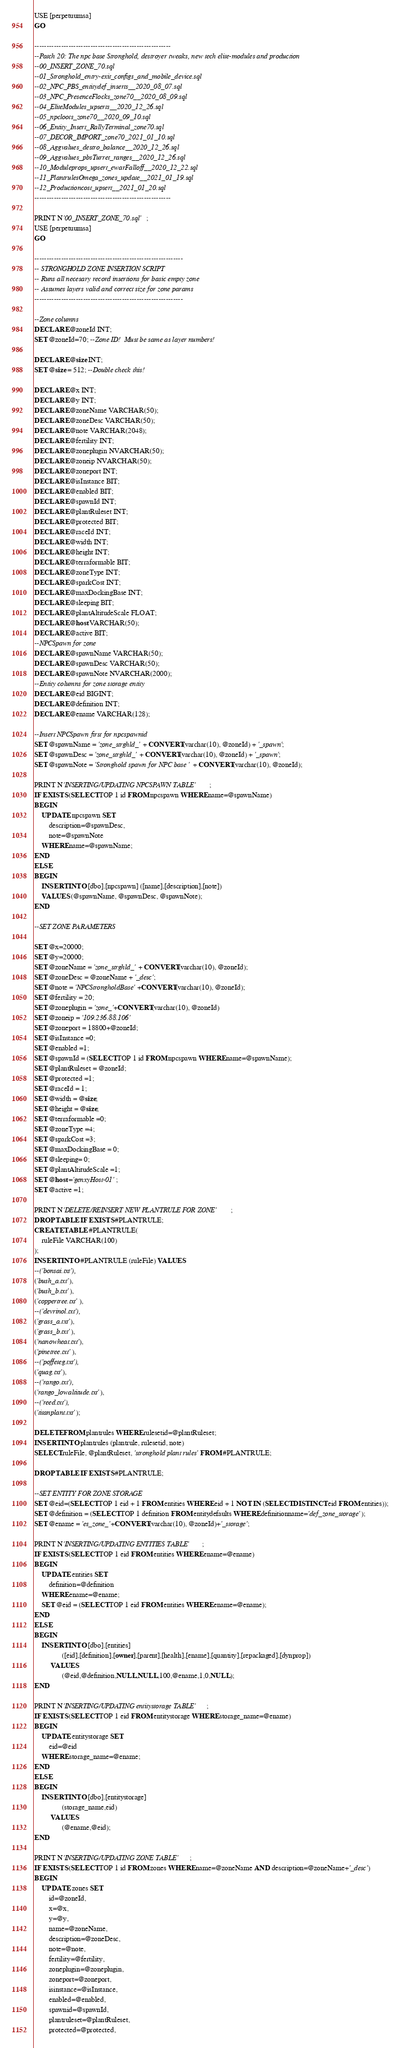<code> <loc_0><loc_0><loc_500><loc_500><_SQL_>USE [perpetuumsa]
GO

--------------------------------------------------------
--Patch 20: The npc base Stronghold, destroyer tweaks, new tech elite-modules and production
--00_INSERT_ZONE_70.sql
--01_Stronghold_entry-exit_configs_and_mobile_device.sql
--02_NPC_PBS_entitydef_inserts__2020_08_07.sql
--03_NPC_PresenceFlocks_zone70__2020_08_09.sql
--04_EliteModules_upserts__2020_12_26.sql
--05_npcloots_zone70__2020_09_10.sql
--06_Entity_Insert_RallyTerminal_zone70.sql
--07_DECOR_IMPORT_zone70_2021_01_10.sql
--08_Aggvalues_destro_balance__2020_12_26.sql
--09_Aggvalues_pbsTurret_ranges__2020_12_26.sql
--10_Moduleprops_upsert_ewarFalloff__2020_12_22.sql
--11_PlantrulesOmega_zones_update__2021_01_19.sql
--12_Productioncost_upsert__2021_01_20.sql
--------------------------------------------------------

PRINT N'00_INSERT_ZONE_70.sql';
USE [perpetuumsa]
GO

-------------------------------------------------------------
-- STRONGHOLD ZONE INSERTION SCRIPT
-- Runs all necesary record insertions for basic empty zone
-- Assumes layers valid and correct size for zone params
-------------------------------------------------------------

--Zone columns
DECLARE @zoneId INT;
SET @zoneId=70; --Zone ID!  Must be same as layer numbers!

DECLARE @size INT;
SET @size = 512; --Double check this!

DECLARE @x INT;
DECLARE @y INT;
DECLARE @zoneName VARCHAR(50);
DECLARE @zoneDesc VARCHAR(50);
DECLARE @note VARCHAR(2048);
DECLARE @fertility INT;
DECLARE @zoneplugin NVARCHAR(50);
DECLARE @zoneip NVARCHAR(50);
DECLARE @zoneport INT;
DECLARE @isInstance BIT;
DECLARE @enabled BIT;
DECLARE @spawnId INT;
DECLARE @plantRuleset INT;
DECLARE @protected BIT;
DECLARE @raceId INT;
DECLARE @width INT;
DECLARE @height INT;
DECLARE @terraformable BIT;
DECLARE @zoneType INT;
DECLARE @sparkCost INT;
DECLARE @maxDockingBase INT;
DECLARE @sleeping BIT;
DECLARE @plantAltitudeScale FLOAT;
DECLARE @host VARCHAR(50);
DECLARE @active BIT;
--NPCSpawn for zone
DECLARE @spawnName VARCHAR(50);
DECLARE @spawnDesc VARCHAR(50);
DECLARE @spawnNote NVARCHAR(2000);
--Entity columns for zone storage entity
DECLARE @eid BIGINT;
DECLARE @definition INT;
DECLARE @ename VARCHAR(128);

--Insert NPCSpawn first for npcspawnid
SET @spawnName = 'zone_strghld_' + CONVERT(varchar(10), @zoneId) + '_spawn';
SET @spawnDesc = 'zone_strghld_' + CONVERT(varchar(10), @zoneId) + '_spawn';
SET @spawnNote = 'Stronghold spawn for NPC base ' + CONVERT(varchar(10), @zoneId);

PRINT N'INSERTING/UPDATING NPCSPAWN TABLE';
IF EXISTS (SELECT TOP 1 id FROM npcspawn WHERE name=@spawnName)
BEGIN
	UPDATE npcspawn SET
		description=@spawnDesc,
		note=@spawnNote
	WHERE name=@spawnName;
END
ELSE
BEGIN
	INSERT INTO [dbo].[npcspawn] ([name],[description],[note])
	VALUES (@spawnName, @spawnDesc, @spawnNote);
END

--SET ZONE PARAMETERS

SET @x=20000;
SET @y=20000;
SET @zoneName = 'zone_strghld_' + CONVERT(varchar(10), @zoneId);
SET @zoneDesc = @zoneName + '_desc';
SET @note = 'NPCStrongholdBase'+CONVERT(varchar(10), @zoneId);
SET @fertility = 20;
SET @zoneplugin = 'zone_'+CONVERT(varchar(10), @zoneId)
SET @zoneip = '109.236.88.106'
SET @zoneport = 18800+@zoneId;
SET @isInstance =0;
SET @enabled =1;
SET @spawnId = (SELECT TOP 1 id FROM npcspawn WHERE name=@spawnName);
SET @plantRuleset = @zoneId;
SET @protected =1;
SET @raceId = 1;
SET @width = @size;
SET @height = @size;
SET @terraformable =0;
SET @zoneType =4;
SET @sparkCost =3;
SET @maxDockingBase = 0;
SET @sleeping= 0;
SET @plantAltitudeScale =1;
SET @host ='genxyHost-01';
SET @active =1;

PRINT N'DELETE/REINSERT NEW PLANTRULE FOR ZONE';
DROP TABLE IF EXISTS #PLANTRULE;
CREATE TABLE #PLANTRULE(
	ruleFile VARCHAR(100)
);
INSERT INTO #PLANTRULE (ruleFile) VALUES
--('bonsai.txt'),
('bush_a.txt'),
('bush_b.txt'),
('coppertree.txt'),
--('devrinol.txt'),
('grass_a.txt'),
('grass_b.txt'),
('nanowheat.txt'),
('pinetree.txt'),
--('poffeteg.txt'),
('quag.txt'),
--('rango.txt'),
('rango_lowaltitude.txt'),
--('reed.txt'),
('titanplant.txt');

DELETE FROM plantrules WHERE rulesetid=@plantRuleset;
INSERT INTO plantrules (plantrule, rulesetid, note)
SELECT ruleFile, @plantRuleset, 'stronghold plant rules' FROM #PLANTRULE;

DROP TABLE IF EXISTS #PLANTRULE;

--SET ENTITY FOR ZONE STORAGE
SET @eid=(SELECT TOP 1 eid + 1 FROM entities WHERE eid + 1 NOT IN (SELECT DISTINCT eid FROM entities));
SET @definition = (SELECT TOP 1 definition FROM entitydefaults WHERE definitionname='def_zone_storage');
SET @ename = 'es_zone_'+CONVERT(varchar(10), @zoneId)+'_storage';

PRINT N'INSERTING/UPDATING ENTITIES TABLE';
IF EXISTS (SELECT TOP 1 eid FROM entities WHERE ename=@ename)
BEGIN
	UPDATE entities SET
		definition=@definition
	WHERE ename=@ename;
	SET @eid = (SELECT TOP 1 eid FROM entities WHERE ename=@ename);
END
ELSE
BEGIN
	INSERT INTO [dbo].[entities]
			   ([eid],[definition],[owner],[parent],[health],[ename],[quantity],[repackaged],[dynprop])
		 VALUES
			   (@eid,@definition,NULL,NULL,100,@ename,1,0,NULL);
END

PRINT N'INSERTING/UPDATING entitystorage TABLE';
IF EXISTS (SELECT TOP 1 eid FROM entitystorage WHERE storage_name=@ename)
BEGIN
	UPDATE entitystorage SET
		eid=@eid
	WHERE storage_name=@ename;
END
ELSE
BEGIN
	INSERT INTO [dbo].[entitystorage]
			   (storage_name,eid)
		 VALUES
			   (@ename,@eid);
END

PRINT N'INSERTING/UPDATING ZONE TABLE';
IF EXISTS (SELECT TOP 1 id FROM zones WHERE name=@zoneName AND description=@zoneName+'_desc')
BEGIN
	UPDATE zones SET
		id=@zoneId,
		x=@x,
		y=@y,
		name=@zoneName,
		description=@zoneDesc,
		note=@note,
		fertility=@fertility,
		zoneplugin=@zoneplugin,
		zoneport=@zoneport,
		isinstance=@isInstance,
		enabled=@enabled,
		spawnid=@spawnId,
		plantruleset=@plantRuleset,
		protected=@protected,</code> 